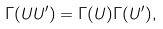Convert formula to latex. <formula><loc_0><loc_0><loc_500><loc_500>\Gamma ( U U ^ { \prime } ) = \Gamma ( U ) \Gamma ( U ^ { \prime } ) ,</formula> 